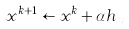Convert formula to latex. <formula><loc_0><loc_0><loc_500><loc_500>x ^ { k + 1 } \leftarrow x ^ { k } + \alpha h _ { x }</formula> 